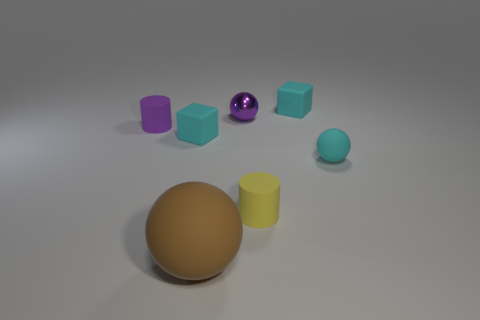How many blocks have the same material as the big brown ball?
Give a very brief answer. 2. What color is the shiny object?
Your answer should be very brief. Purple. Do the cyan matte thing to the left of the yellow object and the tiny purple object that is in front of the tiny metallic ball have the same shape?
Give a very brief answer. No. There is a tiny matte block that is in front of the tiny purple cylinder; what is its color?
Your answer should be compact. Cyan. Is the number of purple cylinders right of the tiny yellow rubber cylinder less than the number of cyan objects on the left side of the purple cylinder?
Your answer should be compact. No. What number of other objects are there of the same material as the big ball?
Give a very brief answer. 5. Does the brown object have the same material as the purple cylinder?
Provide a succinct answer. Yes. What number of other things are the same size as the yellow thing?
Ensure brevity in your answer.  5. There is a matte object that is to the left of the cyan thing on the left side of the tiny yellow rubber cylinder; how big is it?
Make the answer very short. Small. There is a small rubber cylinder that is in front of the small cyan matte thing left of the object in front of the small yellow rubber thing; what color is it?
Offer a very short reply. Yellow. 